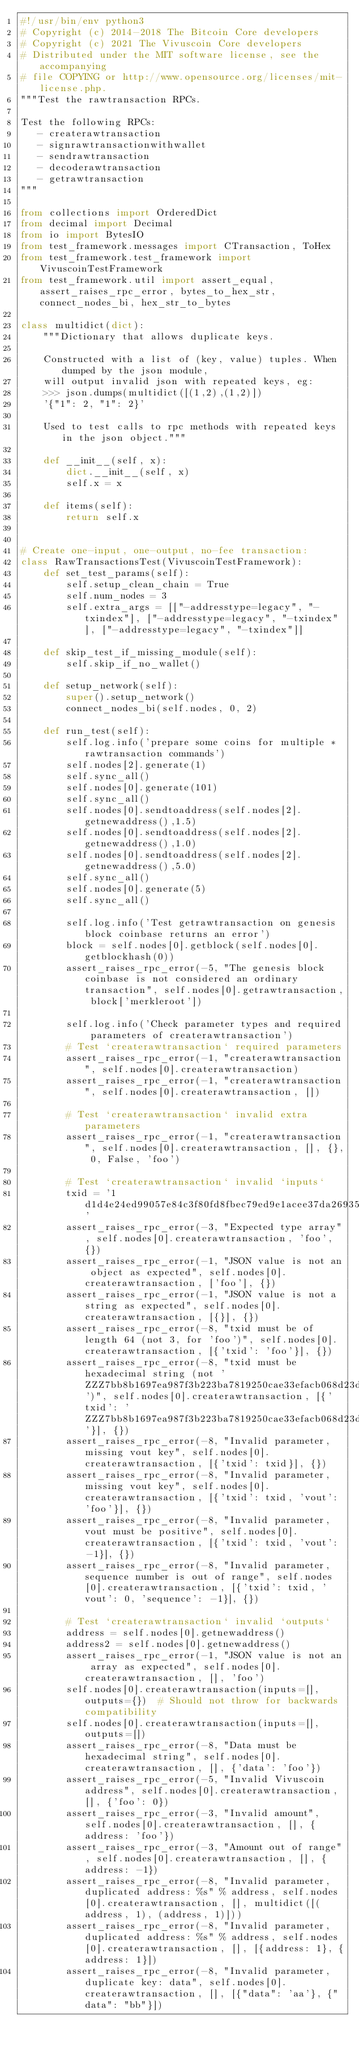Convert code to text. <code><loc_0><loc_0><loc_500><loc_500><_Python_>#!/usr/bin/env python3
# Copyright (c) 2014-2018 The Bitcoin Core developers
# Copyright (c) 2021 The Vivuscoin Core developers
# Distributed under the MIT software license, see the accompanying
# file COPYING or http://www.opensource.org/licenses/mit-license.php.
"""Test the rawtransaction RPCs.

Test the following RPCs:
   - createrawtransaction
   - signrawtransactionwithwallet
   - sendrawtransaction
   - decoderawtransaction
   - getrawtransaction
"""

from collections import OrderedDict
from decimal import Decimal
from io import BytesIO
from test_framework.messages import CTransaction, ToHex
from test_framework.test_framework import VivuscoinTestFramework
from test_framework.util import assert_equal, assert_raises_rpc_error, bytes_to_hex_str, connect_nodes_bi, hex_str_to_bytes

class multidict(dict):
    """Dictionary that allows duplicate keys.

    Constructed with a list of (key, value) tuples. When dumped by the json module,
    will output invalid json with repeated keys, eg:
    >>> json.dumps(multidict([(1,2),(1,2)])
    '{"1": 2, "1": 2}'

    Used to test calls to rpc methods with repeated keys in the json object."""

    def __init__(self, x):
        dict.__init__(self, x)
        self.x = x

    def items(self):
        return self.x


# Create one-input, one-output, no-fee transaction:
class RawTransactionsTest(VivuscoinTestFramework):
    def set_test_params(self):
        self.setup_clean_chain = True
        self.num_nodes = 3
        self.extra_args = [["-addresstype=legacy", "-txindex"], ["-addresstype=legacy", "-txindex"], ["-addresstype=legacy", "-txindex"]]

    def skip_test_if_missing_module(self):
        self.skip_if_no_wallet()

    def setup_network(self):
        super().setup_network()
        connect_nodes_bi(self.nodes, 0, 2)

    def run_test(self):
        self.log.info('prepare some coins for multiple *rawtransaction commands')
        self.nodes[2].generate(1)
        self.sync_all()
        self.nodes[0].generate(101)
        self.sync_all()
        self.nodes[0].sendtoaddress(self.nodes[2].getnewaddress(),1.5)
        self.nodes[0].sendtoaddress(self.nodes[2].getnewaddress(),1.0)
        self.nodes[0].sendtoaddress(self.nodes[2].getnewaddress(),5.0)
        self.sync_all()
        self.nodes[0].generate(5)
        self.sync_all()

        self.log.info('Test getrawtransaction on genesis block coinbase returns an error')
        block = self.nodes[0].getblock(self.nodes[0].getblockhash(0))
        assert_raises_rpc_error(-5, "The genesis block coinbase is not considered an ordinary transaction", self.nodes[0].getrawtransaction, block['merkleroot'])

        self.log.info('Check parameter types and required parameters of createrawtransaction')
        # Test `createrawtransaction` required parameters
        assert_raises_rpc_error(-1, "createrawtransaction", self.nodes[0].createrawtransaction)
        assert_raises_rpc_error(-1, "createrawtransaction", self.nodes[0].createrawtransaction, [])

        # Test `createrawtransaction` invalid extra parameters
        assert_raises_rpc_error(-1, "createrawtransaction", self.nodes[0].createrawtransaction, [], {}, 0, False, 'foo')

        # Test `createrawtransaction` invalid `inputs`
        txid = '1d1d4e24ed99057e84c3f80fd8fbec79ed9e1acee37da269356ecea000000000'
        assert_raises_rpc_error(-3, "Expected type array", self.nodes[0].createrawtransaction, 'foo', {})
        assert_raises_rpc_error(-1, "JSON value is not an object as expected", self.nodes[0].createrawtransaction, ['foo'], {})
        assert_raises_rpc_error(-1, "JSON value is not a string as expected", self.nodes[0].createrawtransaction, [{}], {})
        assert_raises_rpc_error(-8, "txid must be of length 64 (not 3, for 'foo')", self.nodes[0].createrawtransaction, [{'txid': 'foo'}], {})
        assert_raises_rpc_error(-8, "txid must be hexadecimal string (not 'ZZZ7bb8b1697ea987f3b223ba7819250cae33efacb068d23dc24859824a77844')", self.nodes[0].createrawtransaction, [{'txid': 'ZZZ7bb8b1697ea987f3b223ba7819250cae33efacb068d23dc24859824a77844'}], {})
        assert_raises_rpc_error(-8, "Invalid parameter, missing vout key", self.nodes[0].createrawtransaction, [{'txid': txid}], {})
        assert_raises_rpc_error(-8, "Invalid parameter, missing vout key", self.nodes[0].createrawtransaction, [{'txid': txid, 'vout': 'foo'}], {})
        assert_raises_rpc_error(-8, "Invalid parameter, vout must be positive", self.nodes[0].createrawtransaction, [{'txid': txid, 'vout': -1}], {})
        assert_raises_rpc_error(-8, "Invalid parameter, sequence number is out of range", self.nodes[0].createrawtransaction, [{'txid': txid, 'vout': 0, 'sequence': -1}], {})

        # Test `createrawtransaction` invalid `outputs`
        address = self.nodes[0].getnewaddress()
        address2 = self.nodes[0].getnewaddress()
        assert_raises_rpc_error(-1, "JSON value is not an array as expected", self.nodes[0].createrawtransaction, [], 'foo')
        self.nodes[0].createrawtransaction(inputs=[], outputs={})  # Should not throw for backwards compatibility
        self.nodes[0].createrawtransaction(inputs=[], outputs=[])
        assert_raises_rpc_error(-8, "Data must be hexadecimal string", self.nodes[0].createrawtransaction, [], {'data': 'foo'})
        assert_raises_rpc_error(-5, "Invalid Vivuscoin address", self.nodes[0].createrawtransaction, [], {'foo': 0})
        assert_raises_rpc_error(-3, "Invalid amount", self.nodes[0].createrawtransaction, [], {address: 'foo'})
        assert_raises_rpc_error(-3, "Amount out of range", self.nodes[0].createrawtransaction, [], {address: -1})
        assert_raises_rpc_error(-8, "Invalid parameter, duplicated address: %s" % address, self.nodes[0].createrawtransaction, [], multidict([(address, 1), (address, 1)]))
        assert_raises_rpc_error(-8, "Invalid parameter, duplicated address: %s" % address, self.nodes[0].createrawtransaction, [], [{address: 1}, {address: 1}])
        assert_raises_rpc_error(-8, "Invalid parameter, duplicate key: data", self.nodes[0].createrawtransaction, [], [{"data": 'aa'}, {"data": "bb"}])</code> 